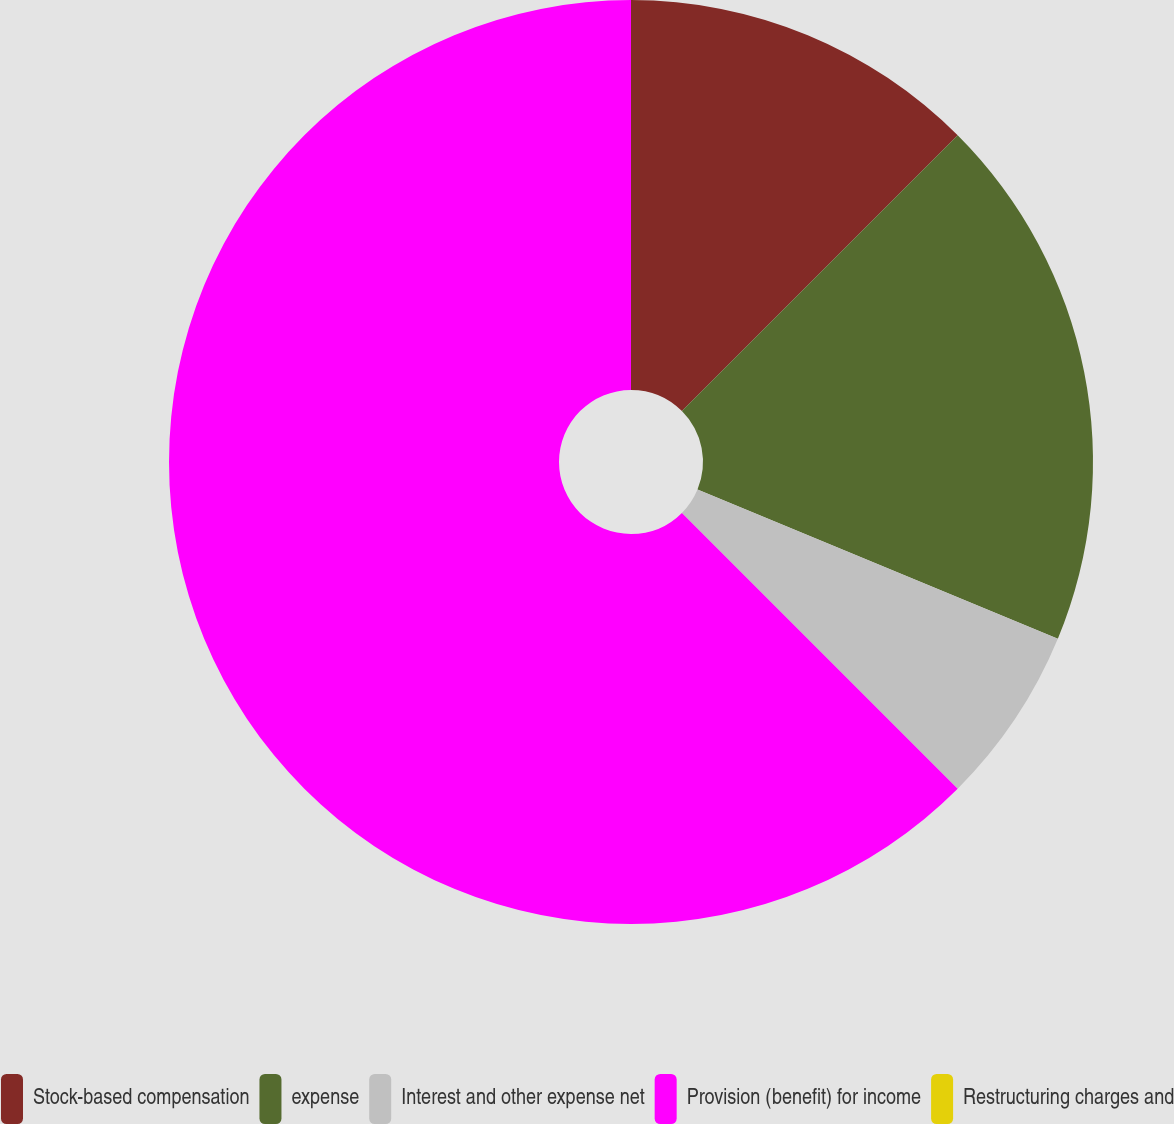Convert chart to OTSL. <chart><loc_0><loc_0><loc_500><loc_500><pie_chart><fcel>Stock-based compensation<fcel>expense<fcel>Interest and other expense net<fcel>Provision (benefit) for income<fcel>Restructuring charges and<nl><fcel>12.5%<fcel>18.75%<fcel>6.25%<fcel>62.5%<fcel>0.0%<nl></chart> 